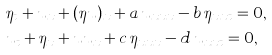<formula> <loc_0><loc_0><loc_500><loc_500>& \eta _ { t } + u _ { x } + ( \eta u ) _ { x } + a \, u _ { x x x } - b \, \eta _ { x x t } = 0 , \\ & u _ { t } + \eta _ { x } + u u _ { x } + c \, \eta _ { x x x } - d \, u _ { x x t } = 0 ,</formula> 